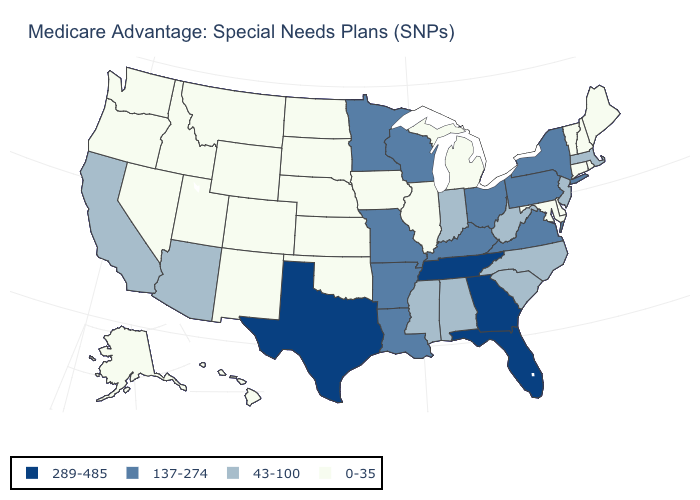Which states have the lowest value in the USA?
Concise answer only. Alaska, Colorado, Connecticut, Delaware, Hawaii, Iowa, Idaho, Illinois, Kansas, Maryland, Maine, Michigan, Montana, North Dakota, Nebraska, New Hampshire, New Mexico, Nevada, Oklahoma, Oregon, Rhode Island, South Dakota, Utah, Vermont, Washington, Wyoming. What is the value of Rhode Island?
Write a very short answer. 0-35. What is the lowest value in the USA?
Concise answer only. 0-35. What is the lowest value in the USA?
Keep it brief. 0-35. Does the first symbol in the legend represent the smallest category?
Write a very short answer. No. Does New Mexico have the same value as West Virginia?
Be succinct. No. Among the states that border Mississippi , which have the highest value?
Short answer required. Tennessee. Among the states that border Wisconsin , which have the lowest value?
Keep it brief. Iowa, Illinois, Michigan. Does Delaware have the highest value in the USA?
Give a very brief answer. No. Does Oregon have a lower value than Kansas?
Be succinct. No. Does the map have missing data?
Keep it brief. No. Does the map have missing data?
Write a very short answer. No. What is the value of Missouri?
Write a very short answer. 137-274. What is the value of California?
Answer briefly. 43-100. Does Delaware have the lowest value in the South?
Keep it brief. Yes. 